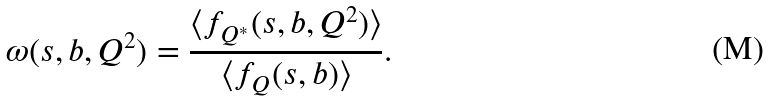<formula> <loc_0><loc_0><loc_500><loc_500>\omega ( s , b , Q ^ { 2 } ) = \frac { \langle f _ { Q ^ { * } } ( s , b , Q ^ { 2 } ) \rangle } { \langle f _ { Q } ( s , b ) \rangle } .</formula> 